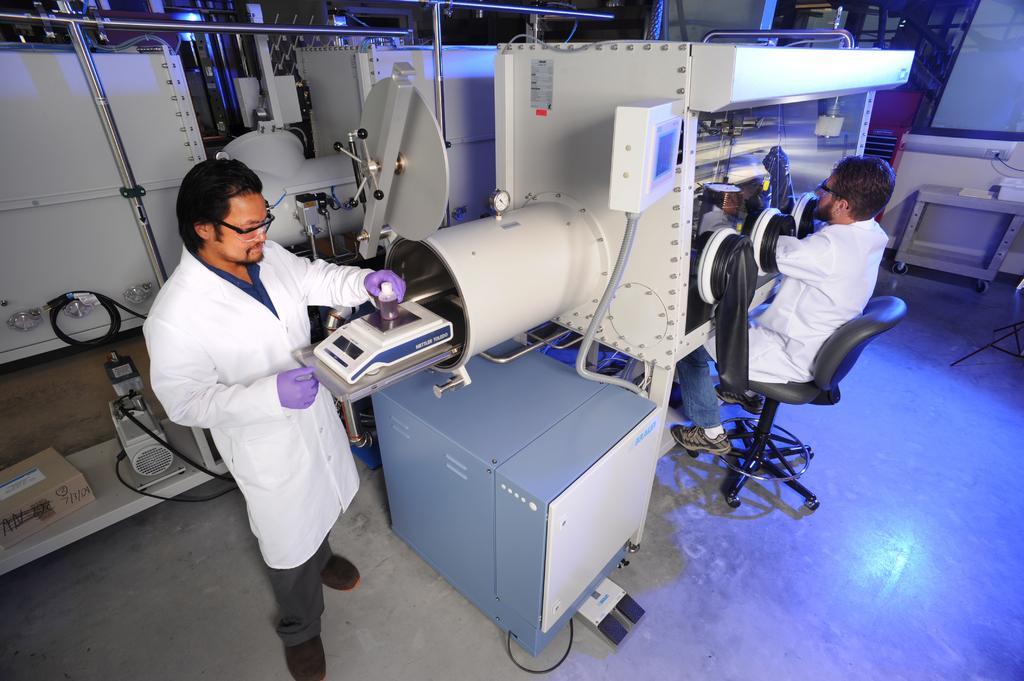Describe this image in one or two sentences. This image is taken indoors. At the bottom of the image there is a floor. In the middle of the image there are a few machines. On the right side of the image there is a table and a man is sitting on the chair. On the left side of the image a man is standing on the floor and he is holding a bottle in his hand. 